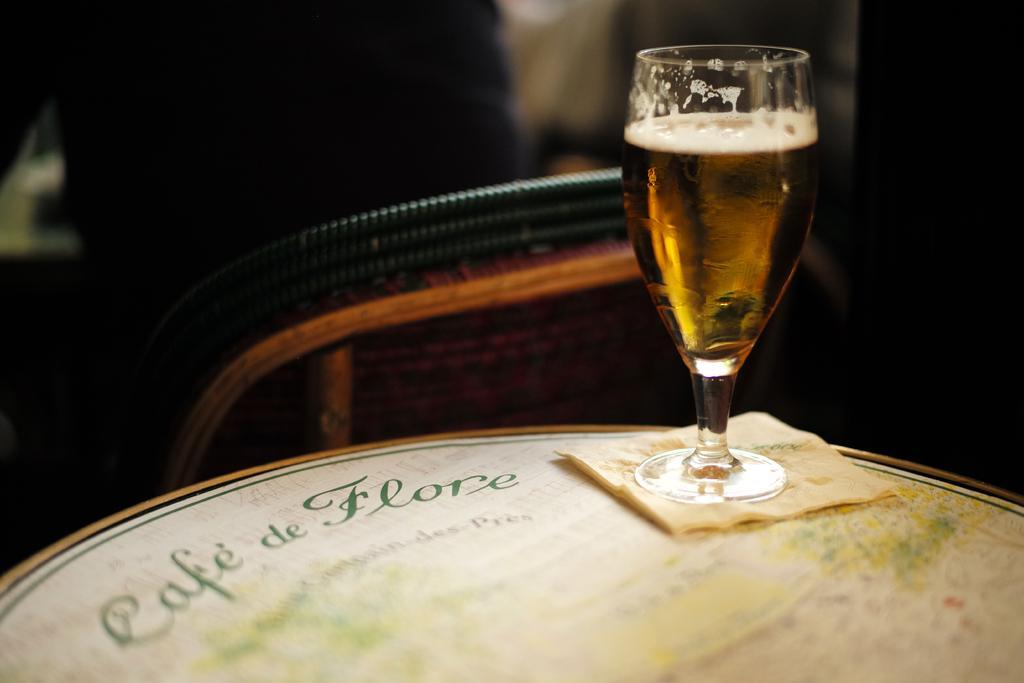Please provide a concise description of this image. In this picture we can see a glass with drink in it and this glass is on a platform, where we can see some objects and in the background we can see it is dark. 